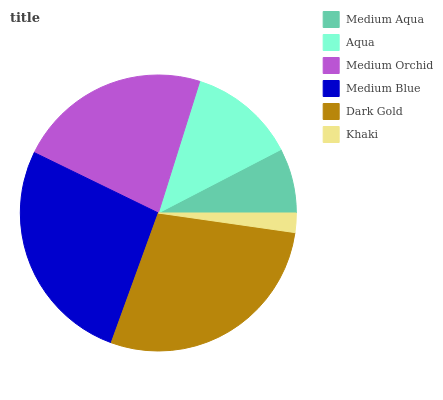Is Khaki the minimum?
Answer yes or no. Yes. Is Dark Gold the maximum?
Answer yes or no. Yes. Is Aqua the minimum?
Answer yes or no. No. Is Aqua the maximum?
Answer yes or no. No. Is Aqua greater than Medium Aqua?
Answer yes or no. Yes. Is Medium Aqua less than Aqua?
Answer yes or no. Yes. Is Medium Aqua greater than Aqua?
Answer yes or no. No. Is Aqua less than Medium Aqua?
Answer yes or no. No. Is Medium Orchid the high median?
Answer yes or no. Yes. Is Aqua the low median?
Answer yes or no. Yes. Is Khaki the high median?
Answer yes or no. No. Is Medium Orchid the low median?
Answer yes or no. No. 